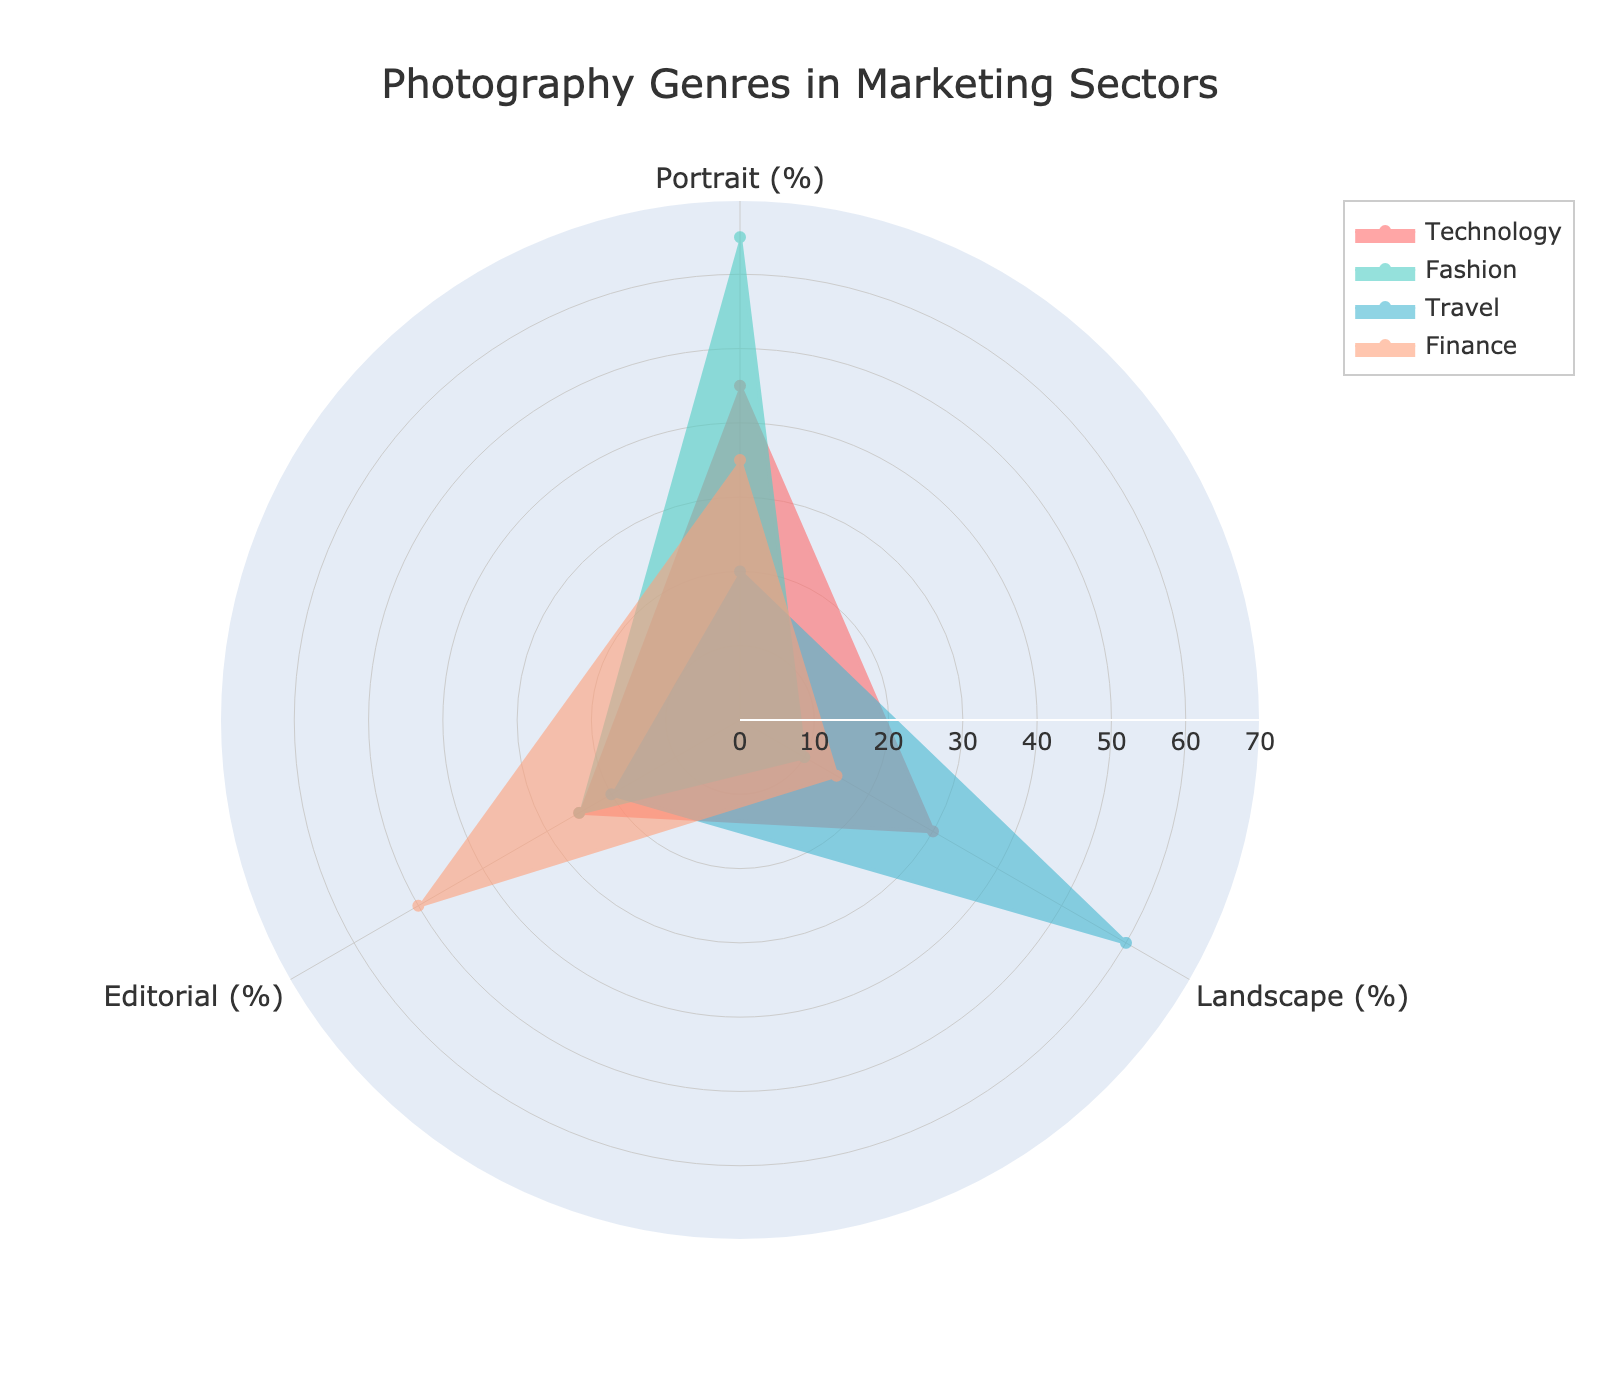What is the title of the radar chart? The title is displayed at the top center of the radar chart for better understanding of the data context.
Answer: Photography Genres in Marketing Sectors Which sector has the highest proportion of portrait photography? By looking at each sector's polygon, the sector with the highest value for portrait photography can be identified.
Answer: Fashion Which photography genre has the smallest proportion in the Finance sector? Look at the values within the Finance sector's polygon; identify the smallest percentage.
Answer: Landscape What is the average proportion of portrait photography across all sectors? Calculate the average of the portrait percentages for Technology, Fashion, Travel, and Finance. (45+65+20+35)/4 = 41.25
Answer: 41.25 Which sector has the most balanced distribution among the three photography genres? Assess the polygons for each sector and find the one where the proportions are most similar.
Answer: Technology Is landscape photography's proportion in the Travel sector higher than in the Technology sector? Compare the landscape percentages for Travel (60%) and Technology (30%).
Answer: Yes Which genre has the highest overall variability among the sectors? Compare the range (max-min) and the standard deviation of proportions for each genre across all sectors.
Answer: Portrait Between portrait and editorial photography, which has a higher average proportion in the Technology sector? Compare the proportions for portrait (45%) and editorial (25%) within Technology.
Answer: Portrait If you sum up the proportions of landscape and editorial photography in the Fashion sector, what do you get? Add the landscape (10%) and editorial (25%) proportions within Fashion. 10 + 25 = 35
Answer: 35 Which sector uses editorial photography the most? Find the sector with the highest proportion of editorial photography by comparing all sectors.
Answer: Finance 